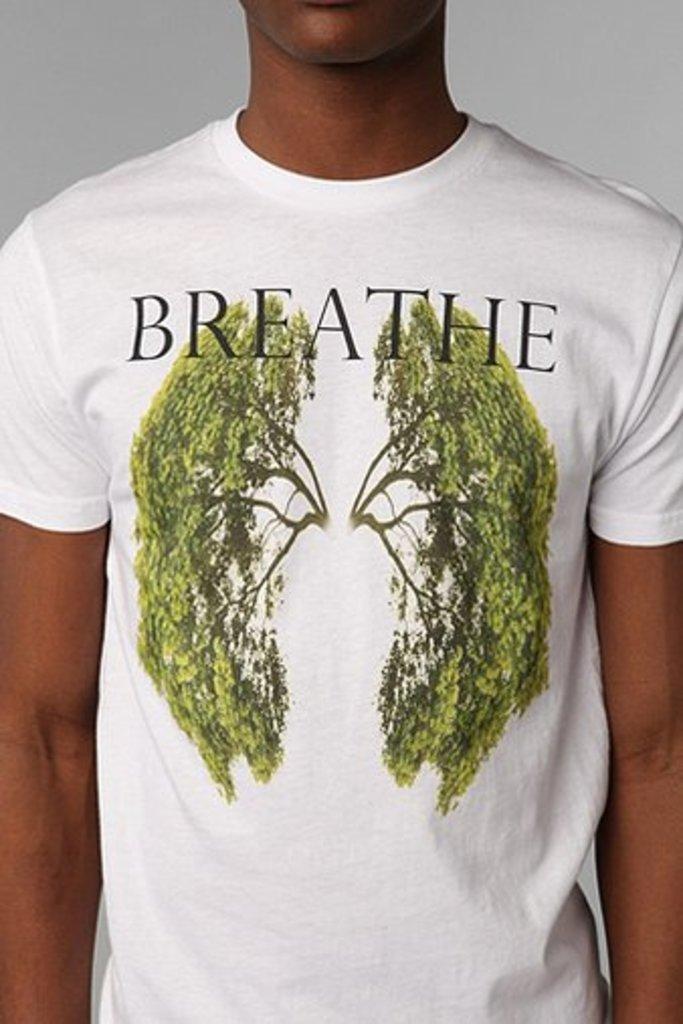Please provide a concise description of this image. In the center of the image there is a person wearing white color t-shirt. 